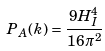Convert formula to latex. <formula><loc_0><loc_0><loc_500><loc_500>P _ { A } ( k ) = \frac { 9 H _ { I } ^ { 4 } } { 1 6 \pi ^ { 2 } }</formula> 